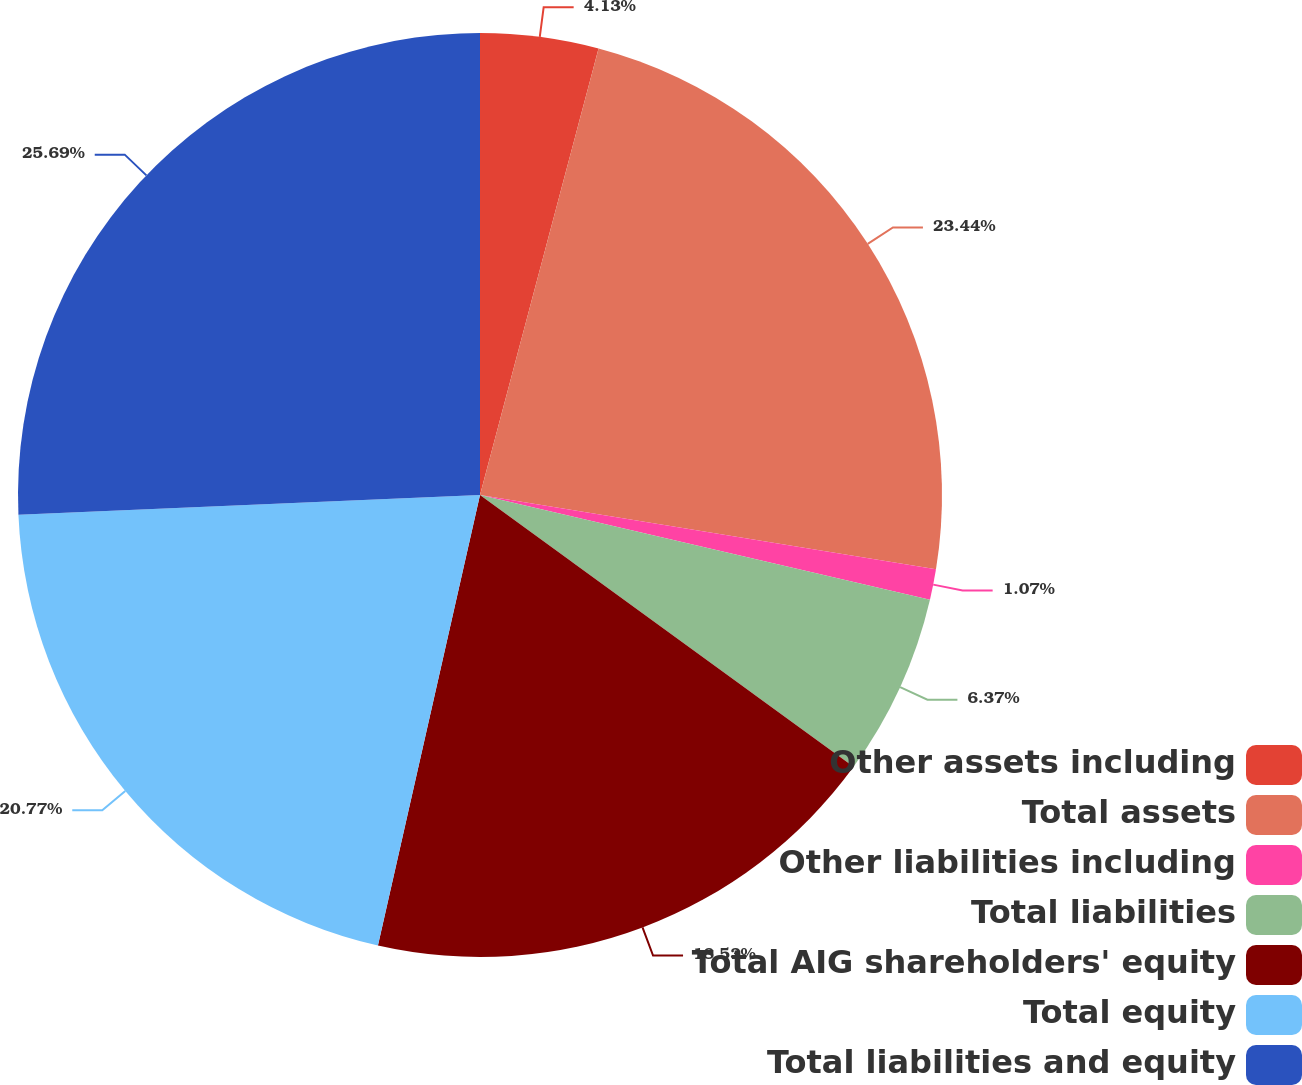Convert chart to OTSL. <chart><loc_0><loc_0><loc_500><loc_500><pie_chart><fcel>Other assets including<fcel>Total assets<fcel>Other liabilities including<fcel>Total liabilities<fcel>Total AIG shareholders' equity<fcel>Total equity<fcel>Total liabilities and equity<nl><fcel>4.13%<fcel>23.44%<fcel>1.07%<fcel>6.37%<fcel>18.53%<fcel>20.77%<fcel>25.68%<nl></chart> 